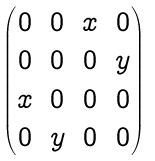Convert formula to latex. <formula><loc_0><loc_0><loc_500><loc_500>\begin{pmatrix} 0 & 0 & x & 0 \\ 0 & 0 & 0 & y \\ x & 0 & 0 & 0 \\ 0 & y & 0 & 0 \end{pmatrix}</formula> 